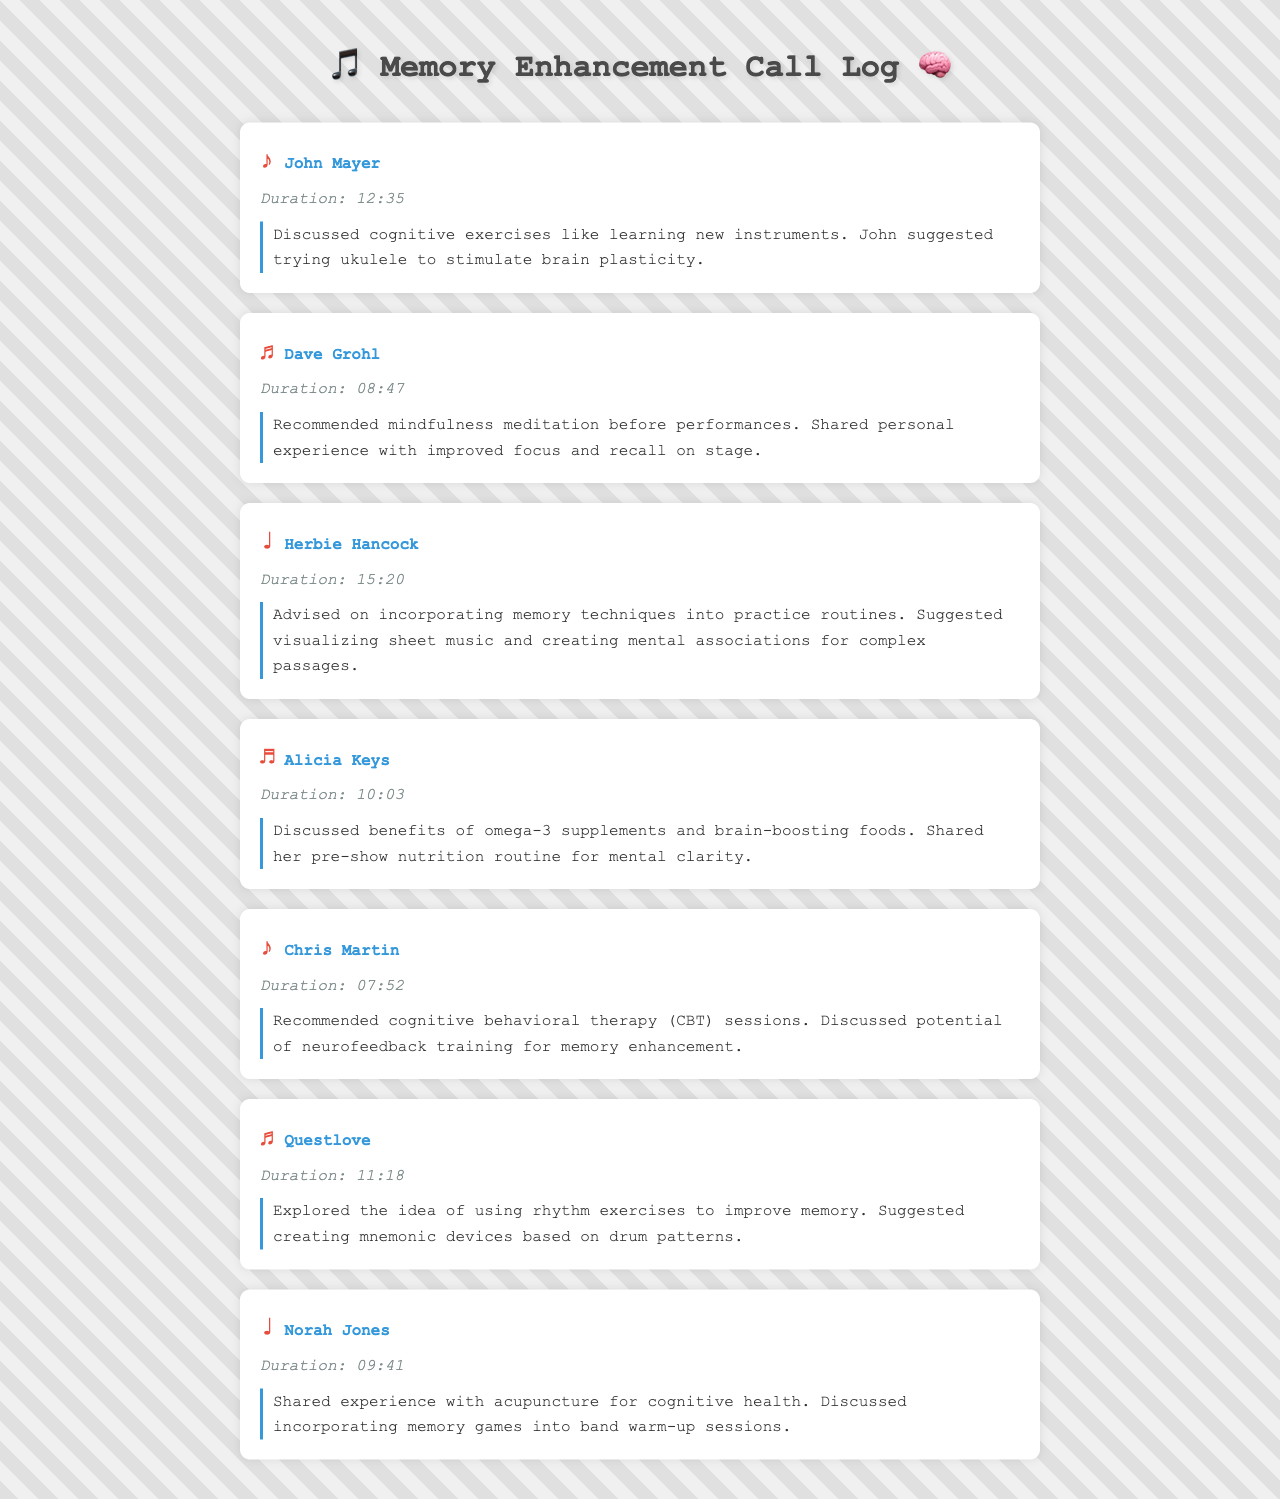What was discussed with John Mayer? The summary states that cognitive exercises like learning new instruments were discussed, and John suggested trying ukulele to stimulate brain plasticity.
Answer: cognitive exercises What was Dave Grohl's recommendation? Dave recommended mindfulness meditation before performances, sharing his personal experience regarding focus and recall.
Answer: mindfulness meditation How long was the call with Herbie Hancock? The duration provided in the document indicates that the call lasted 15 minutes and 20 seconds.
Answer: 15:20 Which supplement was mentioned by Alicia Keys? The summary states that she discussed the benefits of omega-3 supplements for brain health.
Answer: omega-3 supplements What cognitive technique did Chris Martin suggest? Chris recommended cognitive behavioral therapy (CBT) sessions as a potential method for memory enhancement.
Answer: cognitive behavioral therapy What did Questlove explore in his call? He explored the idea of using rhythm exercises to improve memory, suggesting the creation of mnemonic devices based on drum patterns.
Answer: rhythm exercises How long was the call with Norah Jones? The call with Norah lasted for 9 minutes and 41 seconds as noted in the duration.
Answer: 09:41 What was the main topic of discussion with Chris Martin? The main topic was cognitive behavioral therapy and the potential of neurofeedback training for memory enhancement.
Answer: memory enhancement What activity did Norah Jones suggest for warm-up sessions? She discussed incorporating memory games into band warm-up sessions.
Answer: memory games 